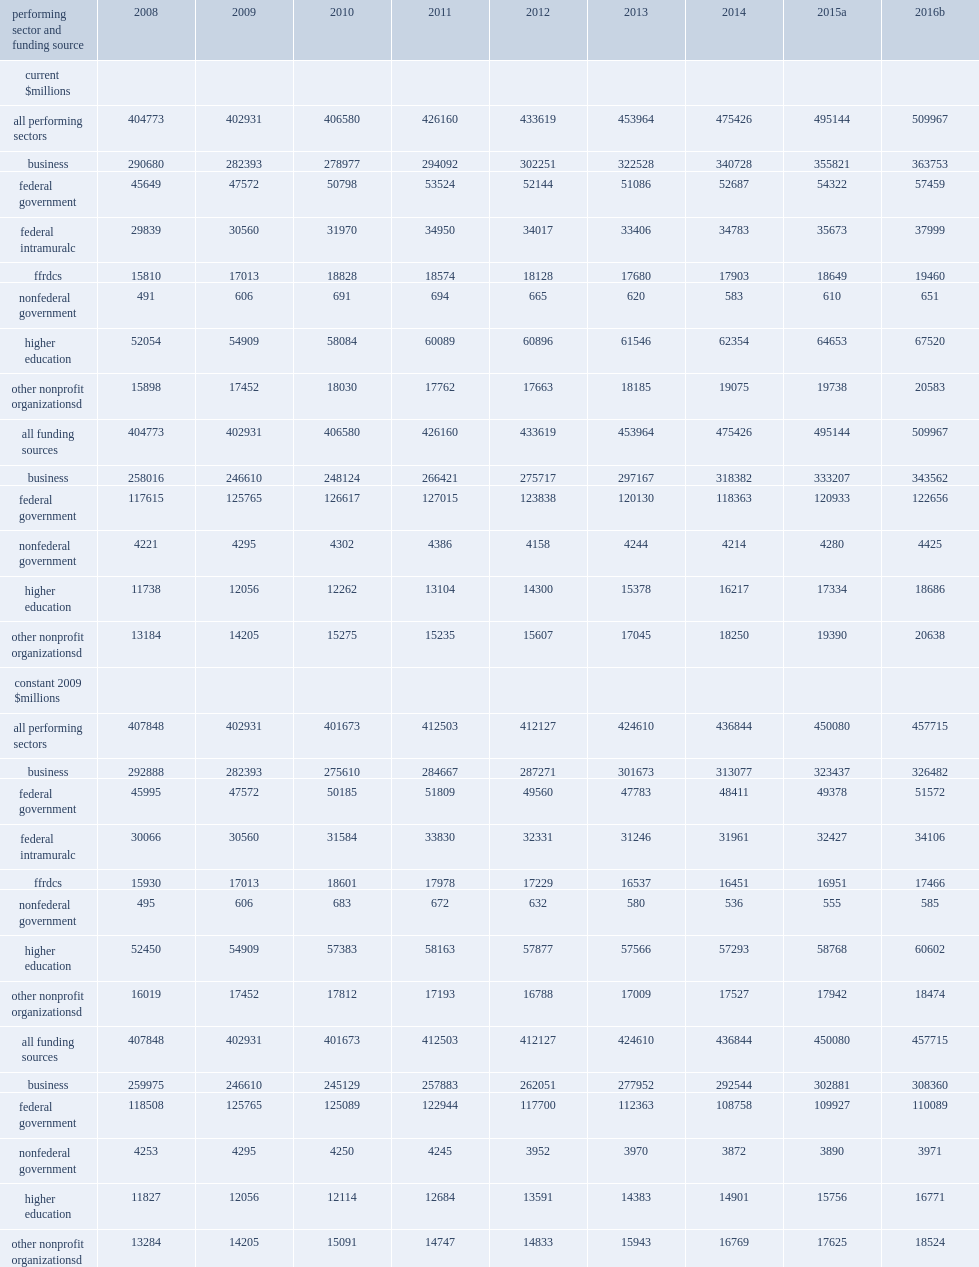Could you parse the entire table? {'header': ['performing sector and funding source', '2008', '2009', '2010', '2011', '2012', '2013', '2014', '2015a', '2016b'], 'rows': [['current $millions', '', '', '', '', '', '', '', '', ''], ['all performing sectors', '404773', '402931', '406580', '426160', '433619', '453964', '475426', '495144', '509967'], ['business', '290680', '282393', '278977', '294092', '302251', '322528', '340728', '355821', '363753'], ['federal government', '45649', '47572', '50798', '53524', '52144', '51086', '52687', '54322', '57459'], ['federal intramuralc', '29839', '30560', '31970', '34950', '34017', '33406', '34783', '35673', '37999'], ['ffrdcs', '15810', '17013', '18828', '18574', '18128', '17680', '17903', '18649', '19460'], ['nonfederal government', '491', '606', '691', '694', '665', '620', '583', '610', '651'], ['higher education', '52054', '54909', '58084', '60089', '60896', '61546', '62354', '64653', '67520'], ['other nonprofit organizationsd', '15898', '17452', '18030', '17762', '17663', '18185', '19075', '19738', '20583'], ['all funding sources', '404773', '402931', '406580', '426160', '433619', '453964', '475426', '495144', '509967'], ['business', '258016', '246610', '248124', '266421', '275717', '297167', '318382', '333207', '343562'], ['federal government', '117615', '125765', '126617', '127015', '123838', '120130', '118363', '120933', '122656'], ['nonfederal government', '4221', '4295', '4302', '4386', '4158', '4244', '4214', '4280', '4425'], ['higher education', '11738', '12056', '12262', '13104', '14300', '15378', '16217', '17334', '18686'], ['other nonprofit organizationsd', '13184', '14205', '15275', '15235', '15607', '17045', '18250', '19390', '20638'], ['constant 2009 $millions', '', '', '', '', '', '', '', '', ''], ['all performing sectors', '407848', '402931', '401673', '412503', '412127', '424610', '436844', '450080', '457715'], ['business', '292888', '282393', '275610', '284667', '287271', '301673', '313077', '323437', '326482'], ['federal government', '45995', '47572', '50185', '51809', '49560', '47783', '48411', '49378', '51572'], ['federal intramuralc', '30066', '30560', '31584', '33830', '32331', '31246', '31961', '32427', '34106'], ['ffrdcs', '15930', '17013', '18601', '17978', '17229', '16537', '16451', '16951', '17466'], ['nonfederal government', '495', '606', '683', '672', '632', '580', '536', '555', '585'], ['higher education', '52450', '54909', '57383', '58163', '57877', '57566', '57293', '58768', '60602'], ['other nonprofit organizationsd', '16019', '17452', '17812', '17193', '16788', '17009', '17527', '17942', '18474'], ['all funding sources', '407848', '402931', '401673', '412503', '412127', '424610', '436844', '450080', '457715'], ['business', '259975', '246610', '245129', '257883', '262051', '277952', '292544', '302881', '308360'], ['federal government', '118508', '125765', '125089', '122944', '117700', '112363', '108758', '109927', '110089'], ['nonfederal government', '4253', '4295', '4250', '4245', '3952', '3970', '3872', '3890', '3971'], ['higher education', '11827', '12056', '12114', '12684', '13591', '14383', '14901', '15756', '16771'], ['other nonprofit organizationsd', '13284', '14205', '15091', '14747', '14833', '15943', '16769', '17625', '18524']]} How many million dollars did research and experimental development (r&d) perform in the united states totaled in 2015? 495144.0. How many dollars of the estimated total for 2016, based on performerreported expectations? 509967.0. How many million dollars does u.s. r&d total in 2013? 453964.0. How many million dollars does u.s. r&d total in 2014? 475426.0. In 2008, what was the u.s. total million dollars? 404773.0. 